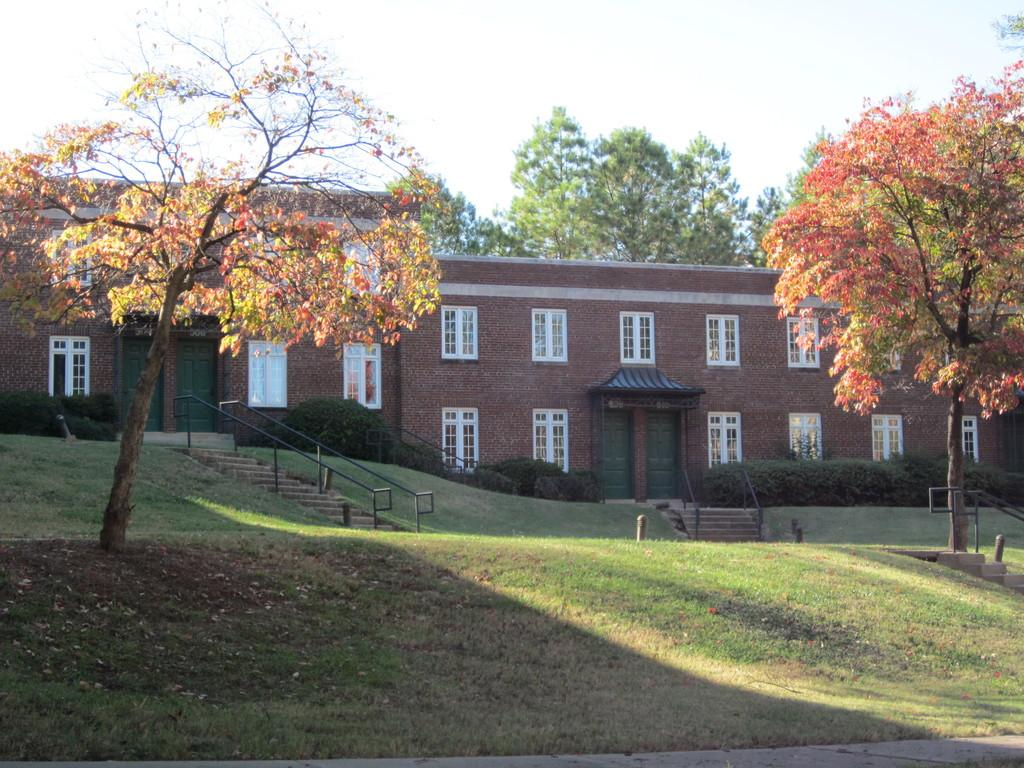What type of structures can be seen in the image? There are houses in the image. What other natural elements are present in the image? There are trees in the image. What can be seen in the background of the image? The sky is visible behind the trees in the image. What news is being reported on the houses in the image? There is no news being reported in the image; it simply shows houses, trees, and the sky. Is there snow visible on the houses in the image? There is no snow visible in the image; it does not mention any weather conditions. 